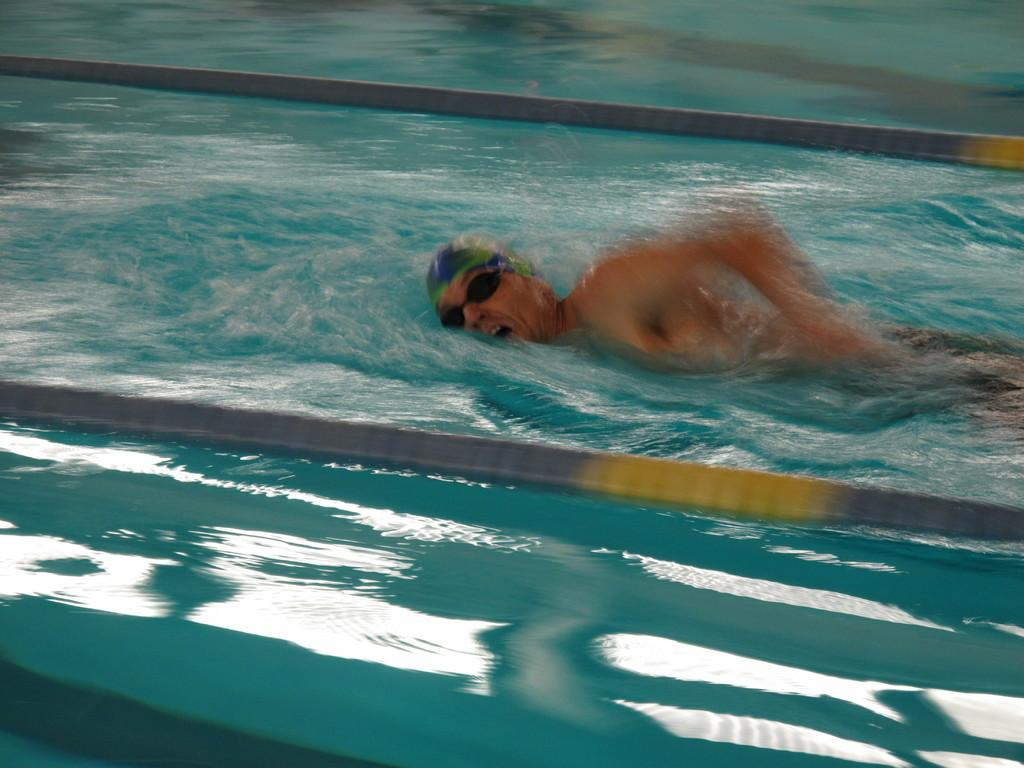Who is present in the image? There is a man in the image. What is the man doing in the image? The man is swimming in the water. What color is the man's collar in the image? There is no mention of a collar in the image, as the man is swimming in the water and not wearing any clothing. 